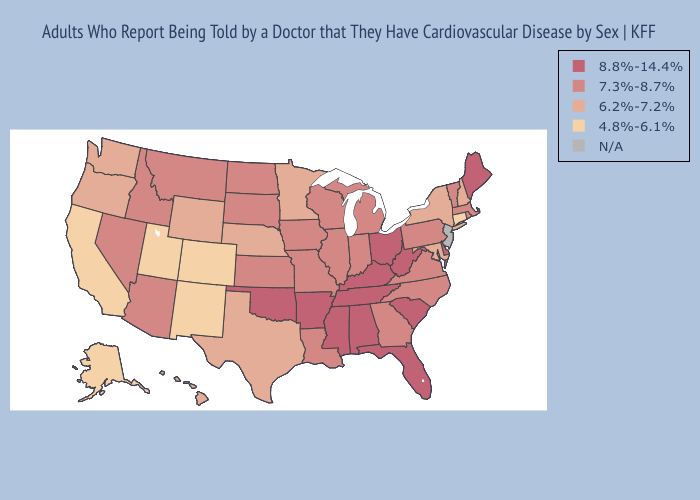Which states have the lowest value in the USA?
Be succinct. Alaska, California, Colorado, Connecticut, New Mexico, Utah. Does Maine have the lowest value in the Northeast?
Concise answer only. No. Name the states that have a value in the range 8.8%-14.4%?
Give a very brief answer. Alabama, Arkansas, Delaware, Florida, Kentucky, Maine, Mississippi, Ohio, Oklahoma, South Carolina, Tennessee, West Virginia. What is the lowest value in the USA?
Give a very brief answer. 4.8%-6.1%. Name the states that have a value in the range 4.8%-6.1%?
Write a very short answer. Alaska, California, Colorado, Connecticut, New Mexico, Utah. Among the states that border Georgia , does North Carolina have the highest value?
Write a very short answer. No. What is the value of Wyoming?
Concise answer only. 6.2%-7.2%. What is the value of Rhode Island?
Write a very short answer. 7.3%-8.7%. Which states hav the highest value in the West?
Write a very short answer. Arizona, Idaho, Montana, Nevada. What is the value of New Hampshire?
Give a very brief answer. 6.2%-7.2%. Which states have the lowest value in the West?
Be succinct. Alaska, California, Colorado, New Mexico, Utah. Does South Dakota have the lowest value in the MidWest?
Be succinct. No. What is the value of Utah?
Write a very short answer. 4.8%-6.1%. 